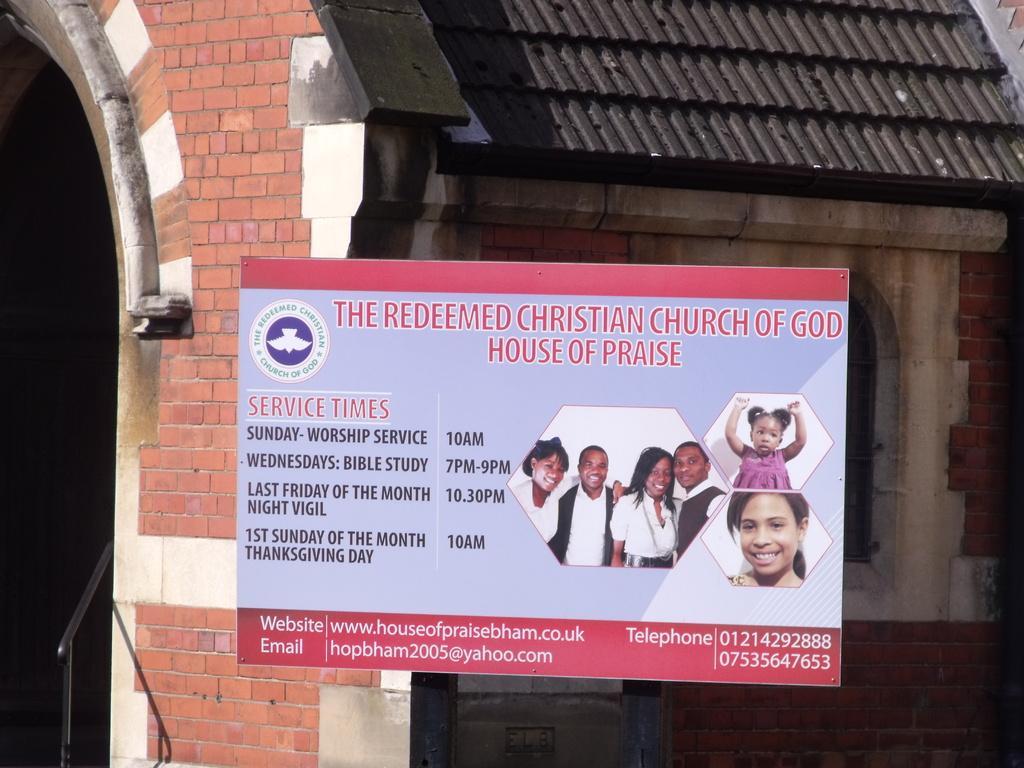How would you summarize this image in a sentence or two? In this image there is a display board with church timings on it, behind the board there is a church. 